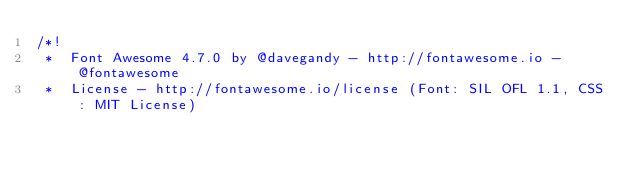<code> <loc_0><loc_0><loc_500><loc_500><_CSS_>/*!
 *  Font Awesome 4.7.0 by @davegandy - http://fontawesome.io - @fontawesome
 *  License - http://fontawesome.io/license (Font: SIL OFL 1.1, CSS: MIT License)</code> 